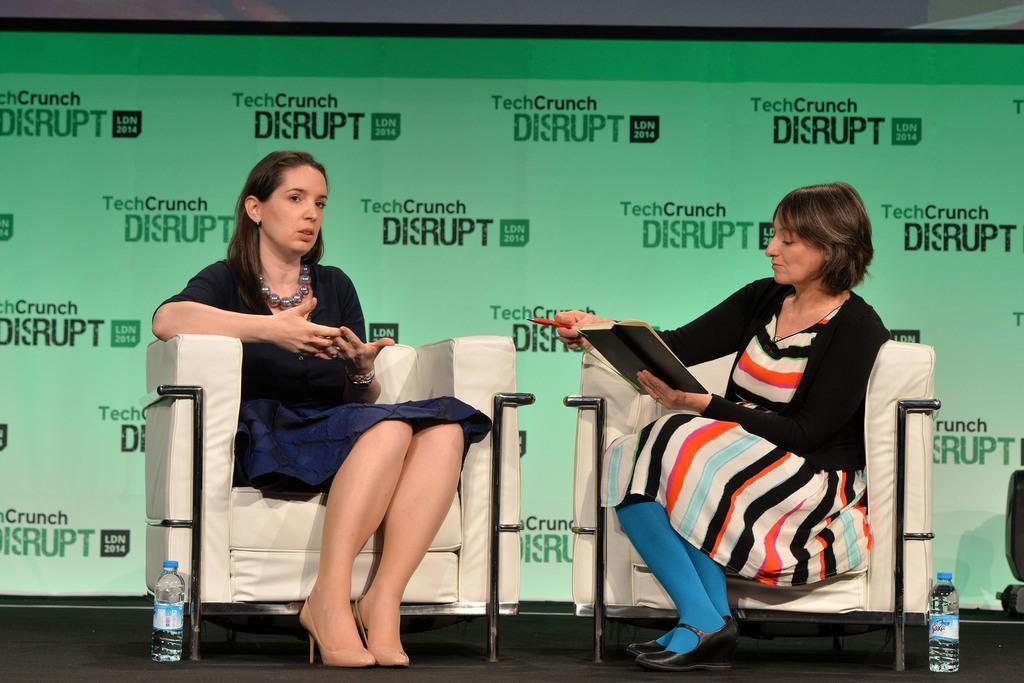Can you describe this image briefly? In this picture I see couple of women seated on the chairs and a woman holding a book in her hand and I see couple of bottles and a advertisement hoarding on the back and we see text on the hoarding. 